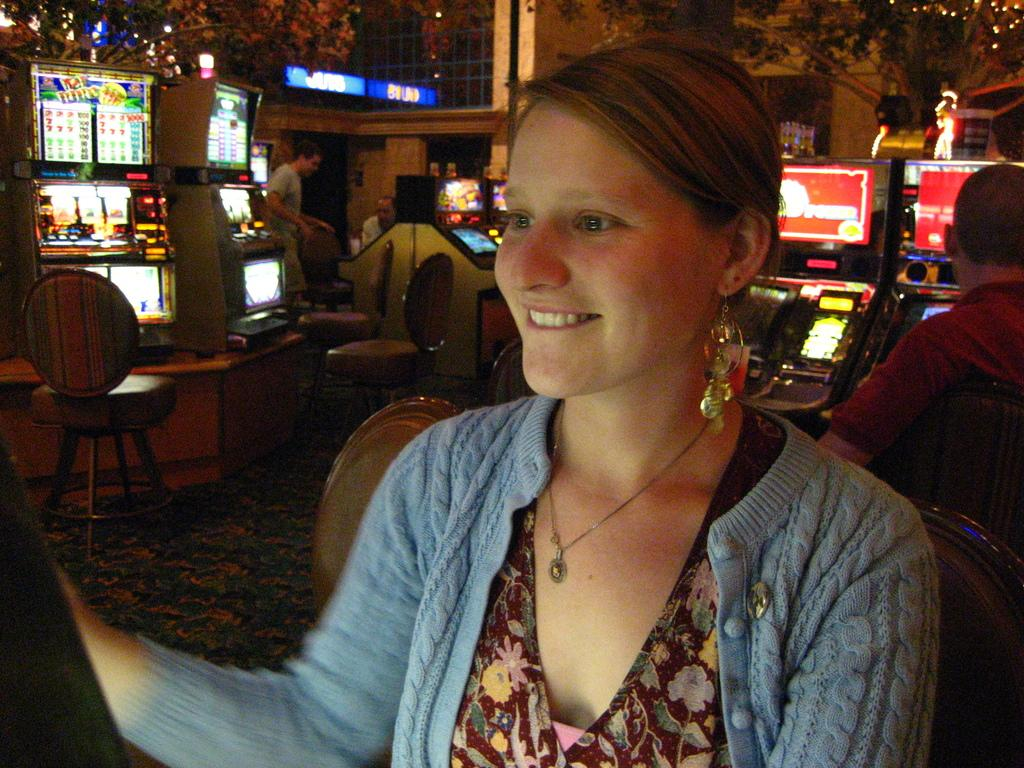How many people are in the image? There are persons in the image, but the exact number is not specified. What are the persons wearing? The persons are wearing clothes. What objects are located in the middle of the image? There are chairs and monitors in the middle of the image. What is the current hour displayed on the monitors in the image? There is no information about the time or any hour displayed on the monitors in the image. What type of school is depicted in the image? There is no indication of a school or any educational setting in the image. 